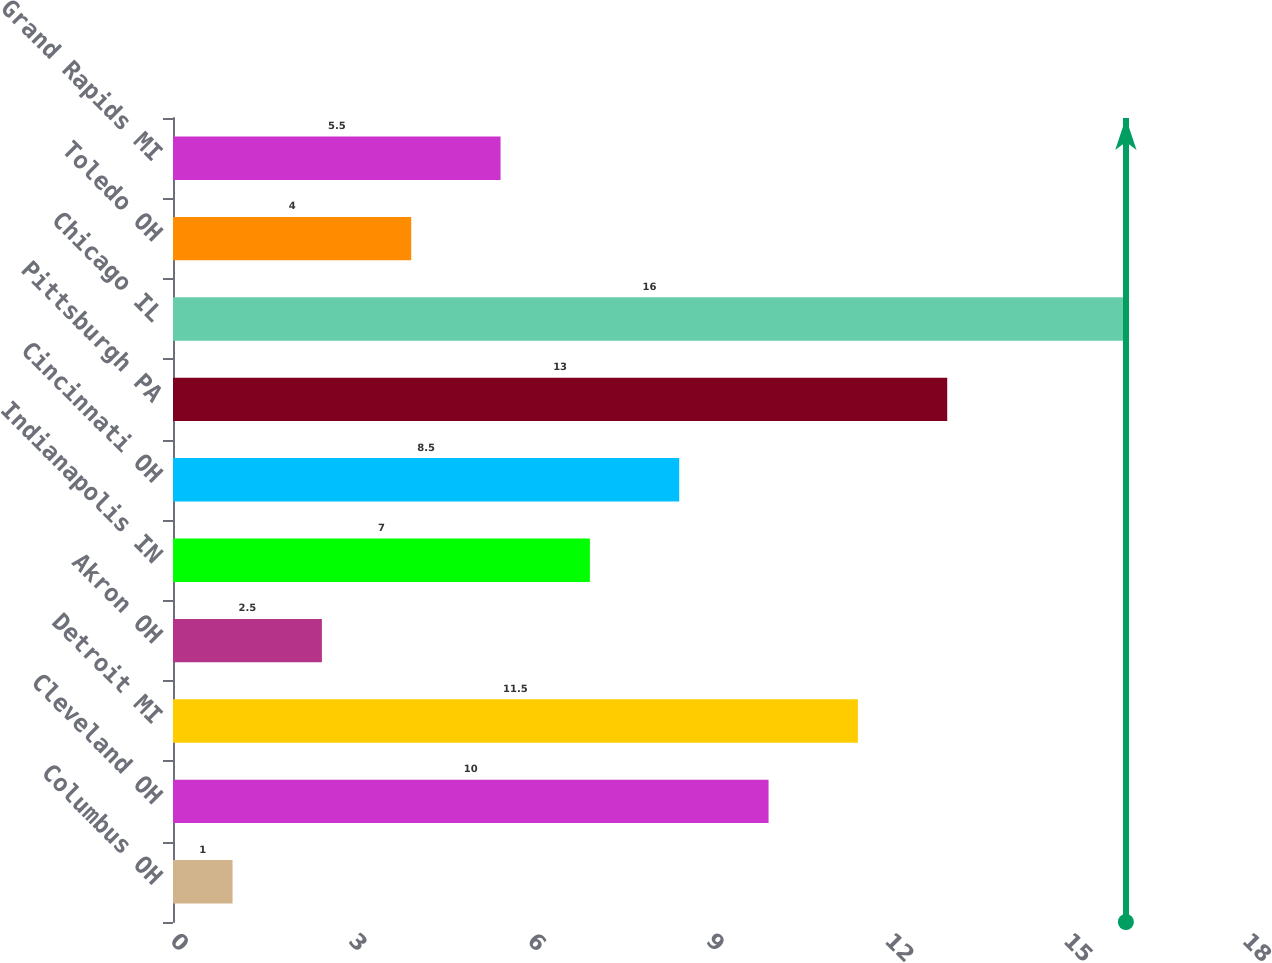Convert chart. <chart><loc_0><loc_0><loc_500><loc_500><bar_chart><fcel>Columbus OH<fcel>Cleveland OH<fcel>Detroit MI<fcel>Akron OH<fcel>Indianapolis IN<fcel>Cincinnati OH<fcel>Pittsburgh PA<fcel>Chicago IL<fcel>Toledo OH<fcel>Grand Rapids MI<nl><fcel>1<fcel>10<fcel>11.5<fcel>2.5<fcel>7<fcel>8.5<fcel>13<fcel>16<fcel>4<fcel>5.5<nl></chart> 